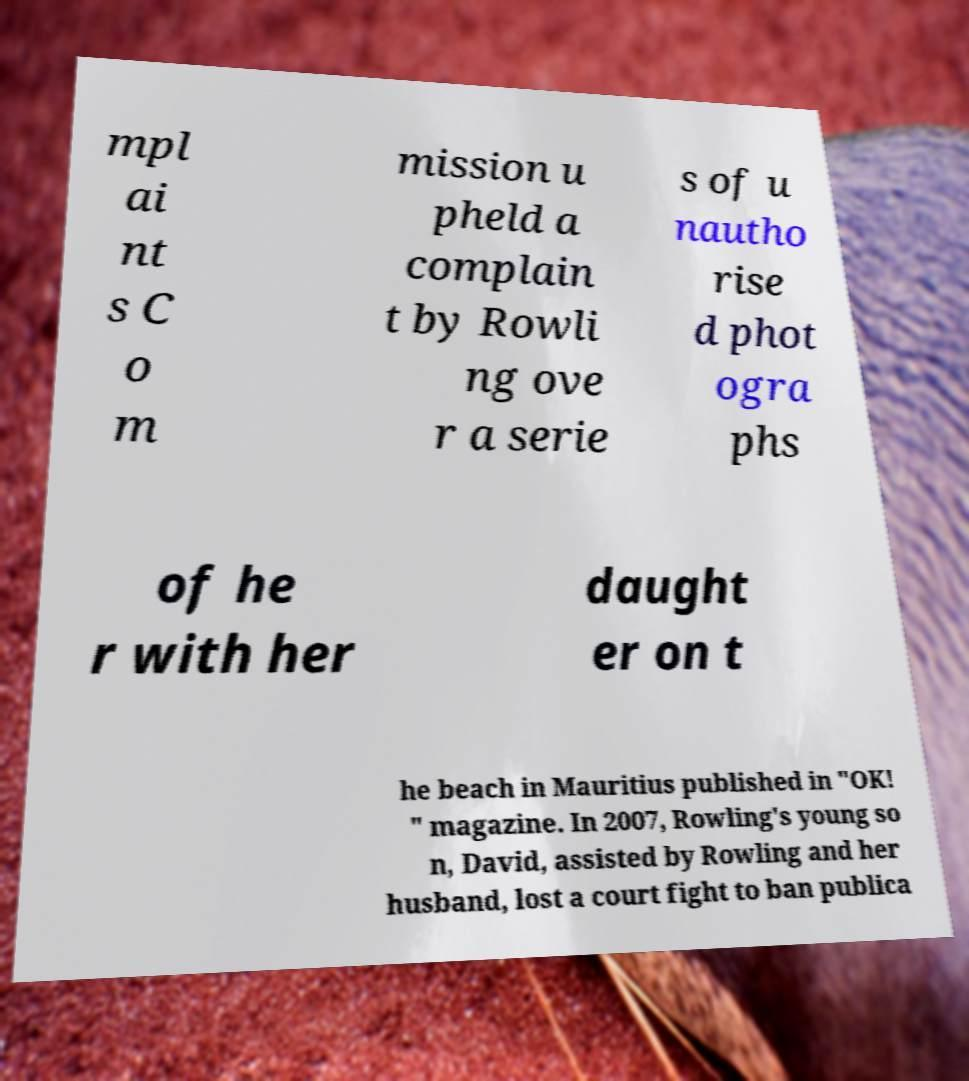Please identify and transcribe the text found in this image. mpl ai nt s C o m mission u pheld a complain t by Rowli ng ove r a serie s of u nautho rise d phot ogra phs of he r with her daught er on t he beach in Mauritius published in "OK! " magazine. In 2007, Rowling's young so n, David, assisted by Rowling and her husband, lost a court fight to ban publica 